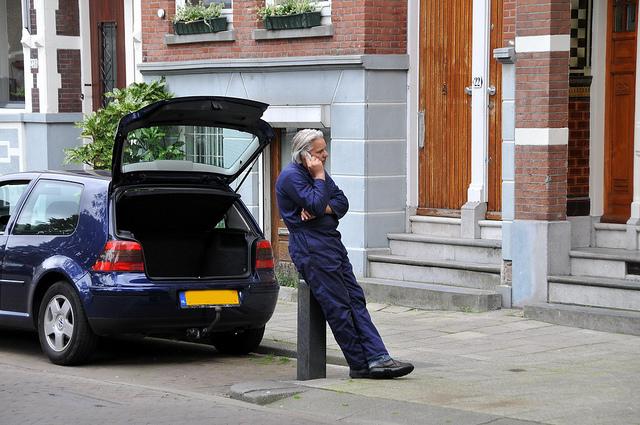Is the man using a public phone?
Quick response, please. No. Is the car's trunk door open or closed?
Keep it brief. Open. What is the man doing?
Give a very brief answer. Talking on phone. What country is this in?
Concise answer only. England. 